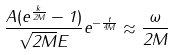Convert formula to latex. <formula><loc_0><loc_0><loc_500><loc_500>\frac { A ( e ^ { \frac { k } { 2 M } } - 1 ) } { \sqrt { 2 M } E } e ^ { - \frac { t } { 4 M } } \approx \frac { \omega } { 2 M }</formula> 